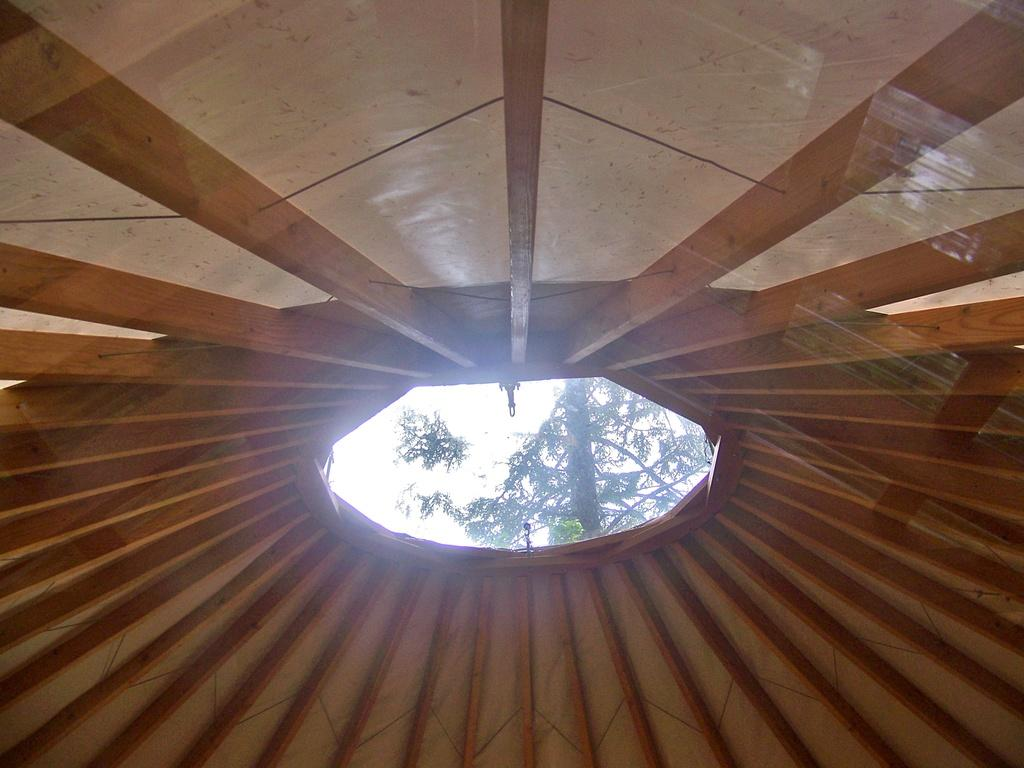What type of shelter is visible in the image? There is a tent in the image. What natural element can be seen in the image? There is a tree in the image. What type of stick is being used to apply cream to the animal in the image? There is no stick, cream, or animal present in the image. 